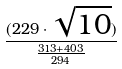Convert formula to latex. <formula><loc_0><loc_0><loc_500><loc_500>\frac { ( 2 2 9 \cdot \sqrt { 1 0 } ) } { \frac { 3 1 3 + 4 0 3 } { 2 9 4 } }</formula> 